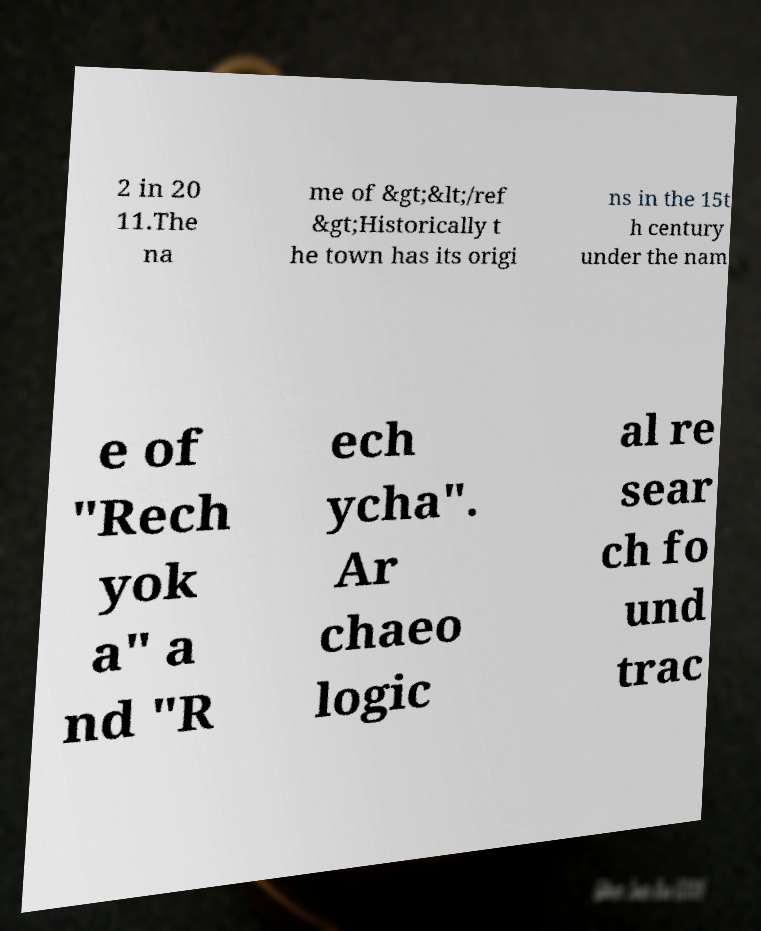There's text embedded in this image that I need extracted. Can you transcribe it verbatim? 2 in 20 11.The na me of &gt;&lt;/ref &gt;Historically t he town has its origi ns in the 15t h century under the nam e of "Rech yok a" a nd "R ech ycha". Ar chaeo logic al re sear ch fo und trac 